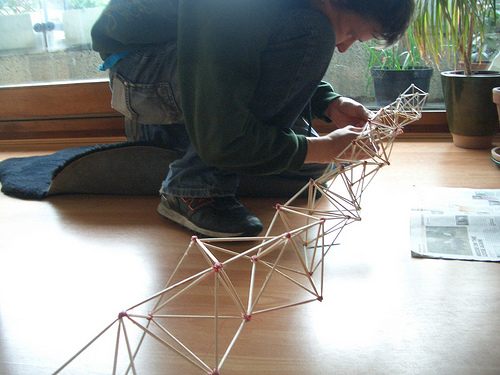<image>
Is there a matches above the floor? Yes. The matches is positioned above the floor in the vertical space, higher up in the scene. Is there a man above the match stick? Yes. The man is positioned above the match stick in the vertical space, higher up in the scene. 